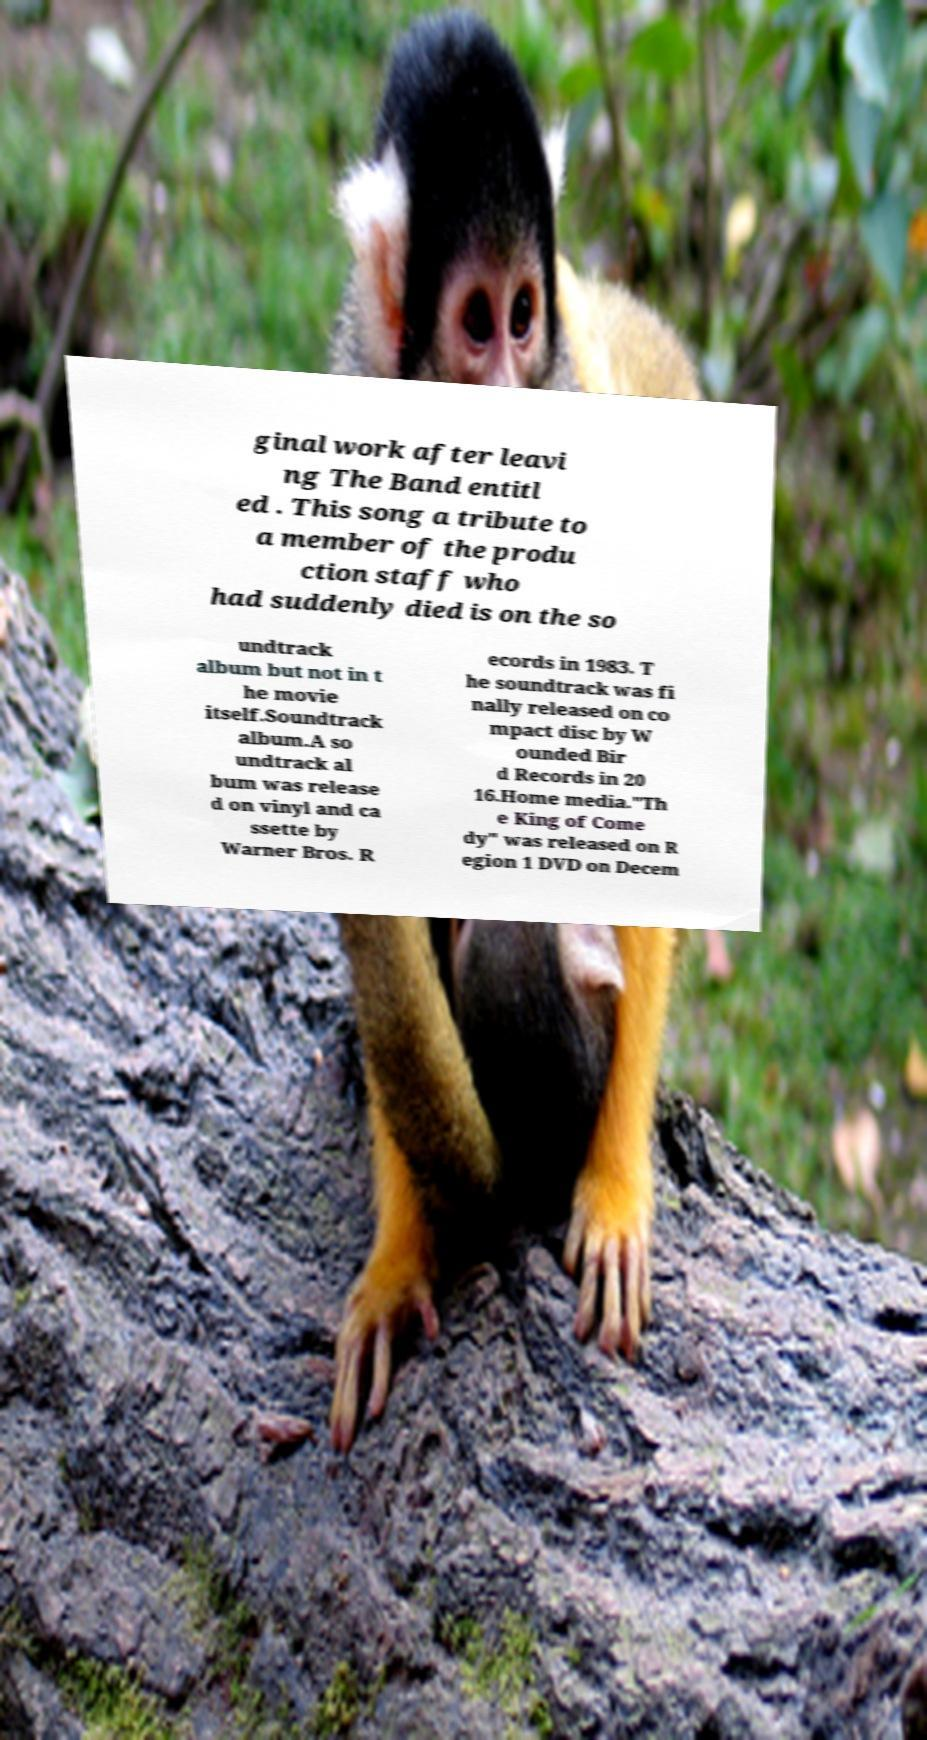Please read and relay the text visible in this image. What does it say? ginal work after leavi ng The Band entitl ed . This song a tribute to a member of the produ ction staff who had suddenly died is on the so undtrack album but not in t he movie itself.Soundtrack album.A so undtrack al bum was release d on vinyl and ca ssette by Warner Bros. R ecords in 1983. T he soundtrack was fi nally released on co mpact disc by W ounded Bir d Records in 20 16.Home media."Th e King of Come dy" was released on R egion 1 DVD on Decem 